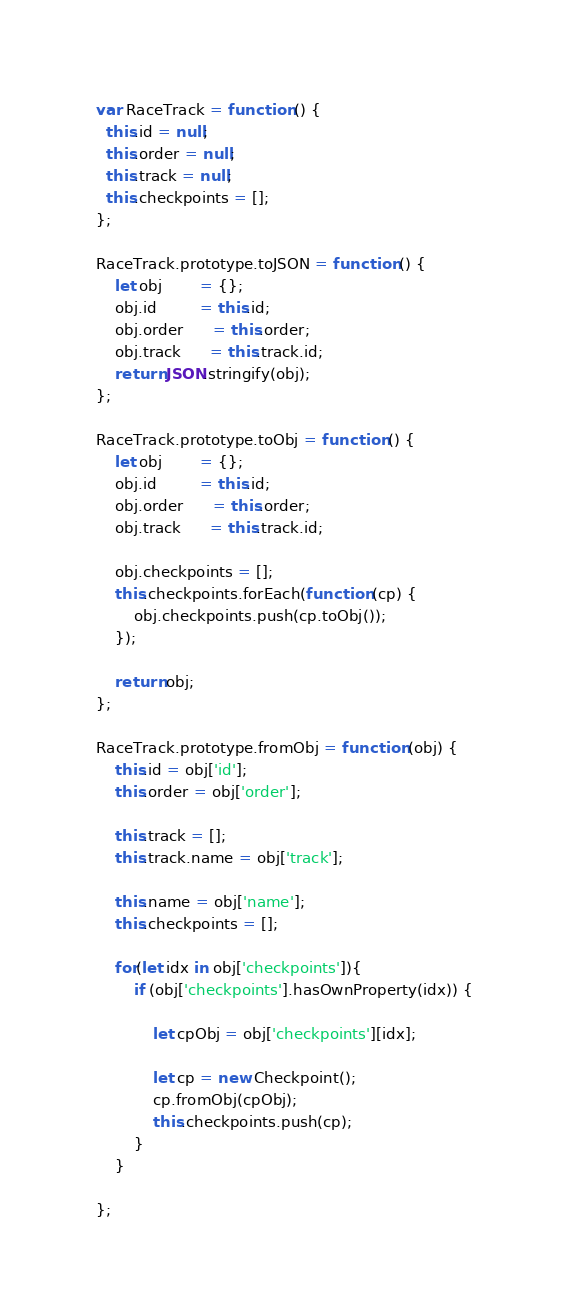Convert code to text. <code><loc_0><loc_0><loc_500><loc_500><_JavaScript_>var RaceTrack = function () {
  this.id = null;
  this.order = null;
  this.track = null;
  this.checkpoints = [];
};

RaceTrack.prototype.toJSON = function () {
    let obj        = {};
    obj.id         = this.id;
    obj.order      = this.order;
    obj.track      = this.track.id;
    return JSON.stringify(obj);
};

RaceTrack.prototype.toObj = function () {
    let obj        = {};
    obj.id         = this.id;
    obj.order      = this.order;
    obj.track      = this.track.id;

    obj.checkpoints = [];
    this.checkpoints.forEach(function (cp) {
        obj.checkpoints.push(cp.toObj());
    });

    return obj;
};

RaceTrack.prototype.fromObj = function (obj) {
    this.id = obj['id'];
    this.order = obj['order'];

    this.track = [];
    this.track.name = obj['track'];

    this.name = obj['name'];
    this.checkpoints = [];

    for(let idx in obj['checkpoints']){
        if (obj['checkpoints'].hasOwnProperty(idx)) {

            let cpObj = obj['checkpoints'][idx];

            let cp = new Checkpoint();
            cp.fromObj(cpObj);
            this.checkpoints.push(cp);
        }
    }

};</code> 